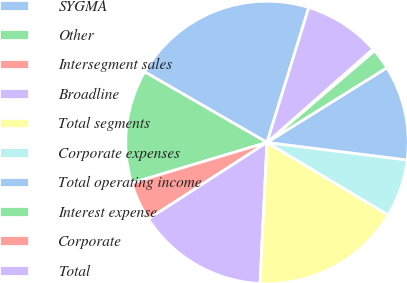Convert chart. <chart><loc_0><loc_0><loc_500><loc_500><pie_chart><fcel>SYGMA<fcel>Other<fcel>Intersegment sales<fcel>Broadline<fcel>Total segments<fcel>Corporate expenses<fcel>Total operating income<fcel>Interest expense<fcel>Corporate<fcel>Total<nl><fcel>21.45%<fcel>12.97%<fcel>4.49%<fcel>15.09%<fcel>17.21%<fcel>6.61%<fcel>10.85%<fcel>2.37%<fcel>0.25%<fcel>8.73%<nl></chart> 